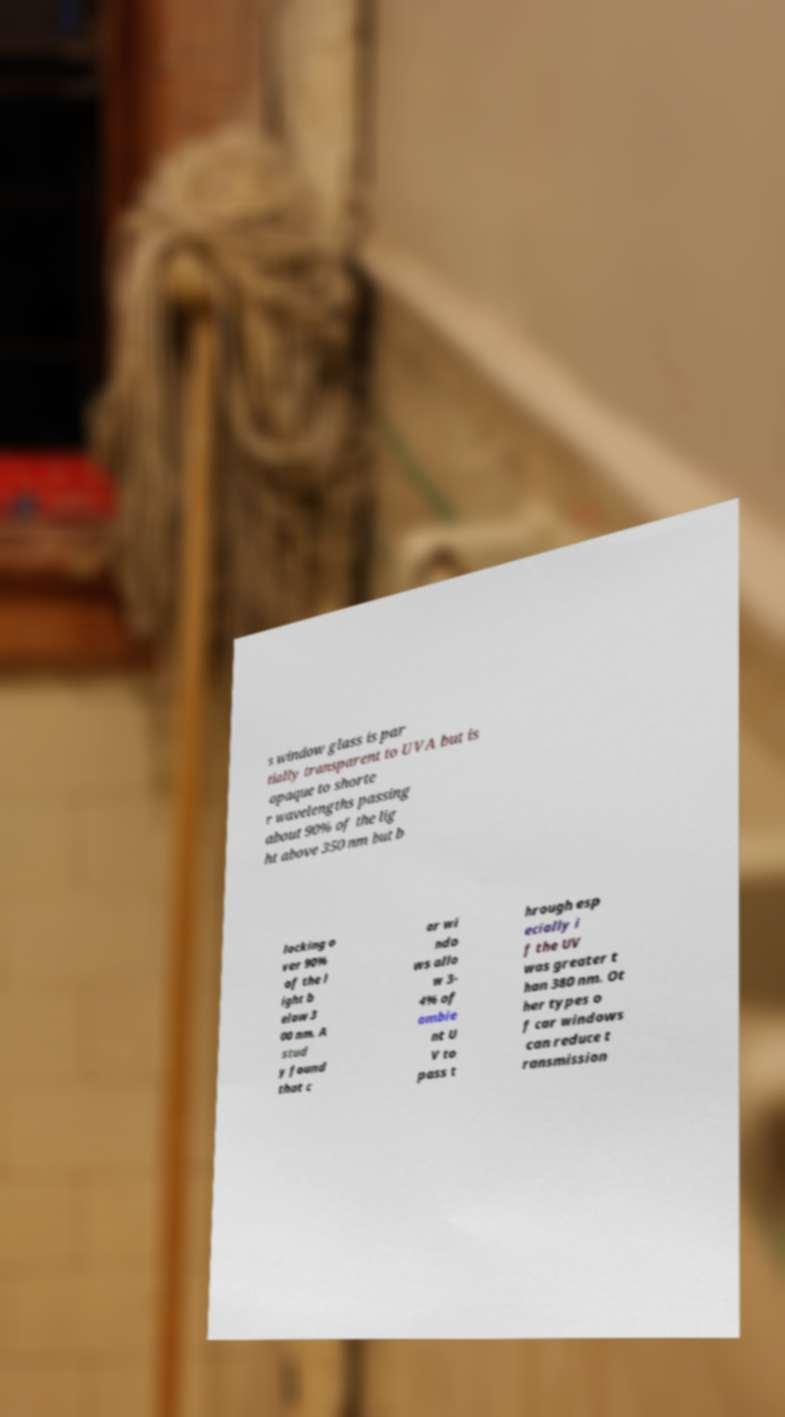For documentation purposes, I need the text within this image transcribed. Could you provide that? s window glass is par tially transparent to UVA but is opaque to shorte r wavelengths passing about 90% of the lig ht above 350 nm but b locking o ver 90% of the l ight b elow 3 00 nm. A stud y found that c ar wi ndo ws allo w 3- 4% of ambie nt U V to pass t hrough esp ecially i f the UV was greater t han 380 nm. Ot her types o f car windows can reduce t ransmission 